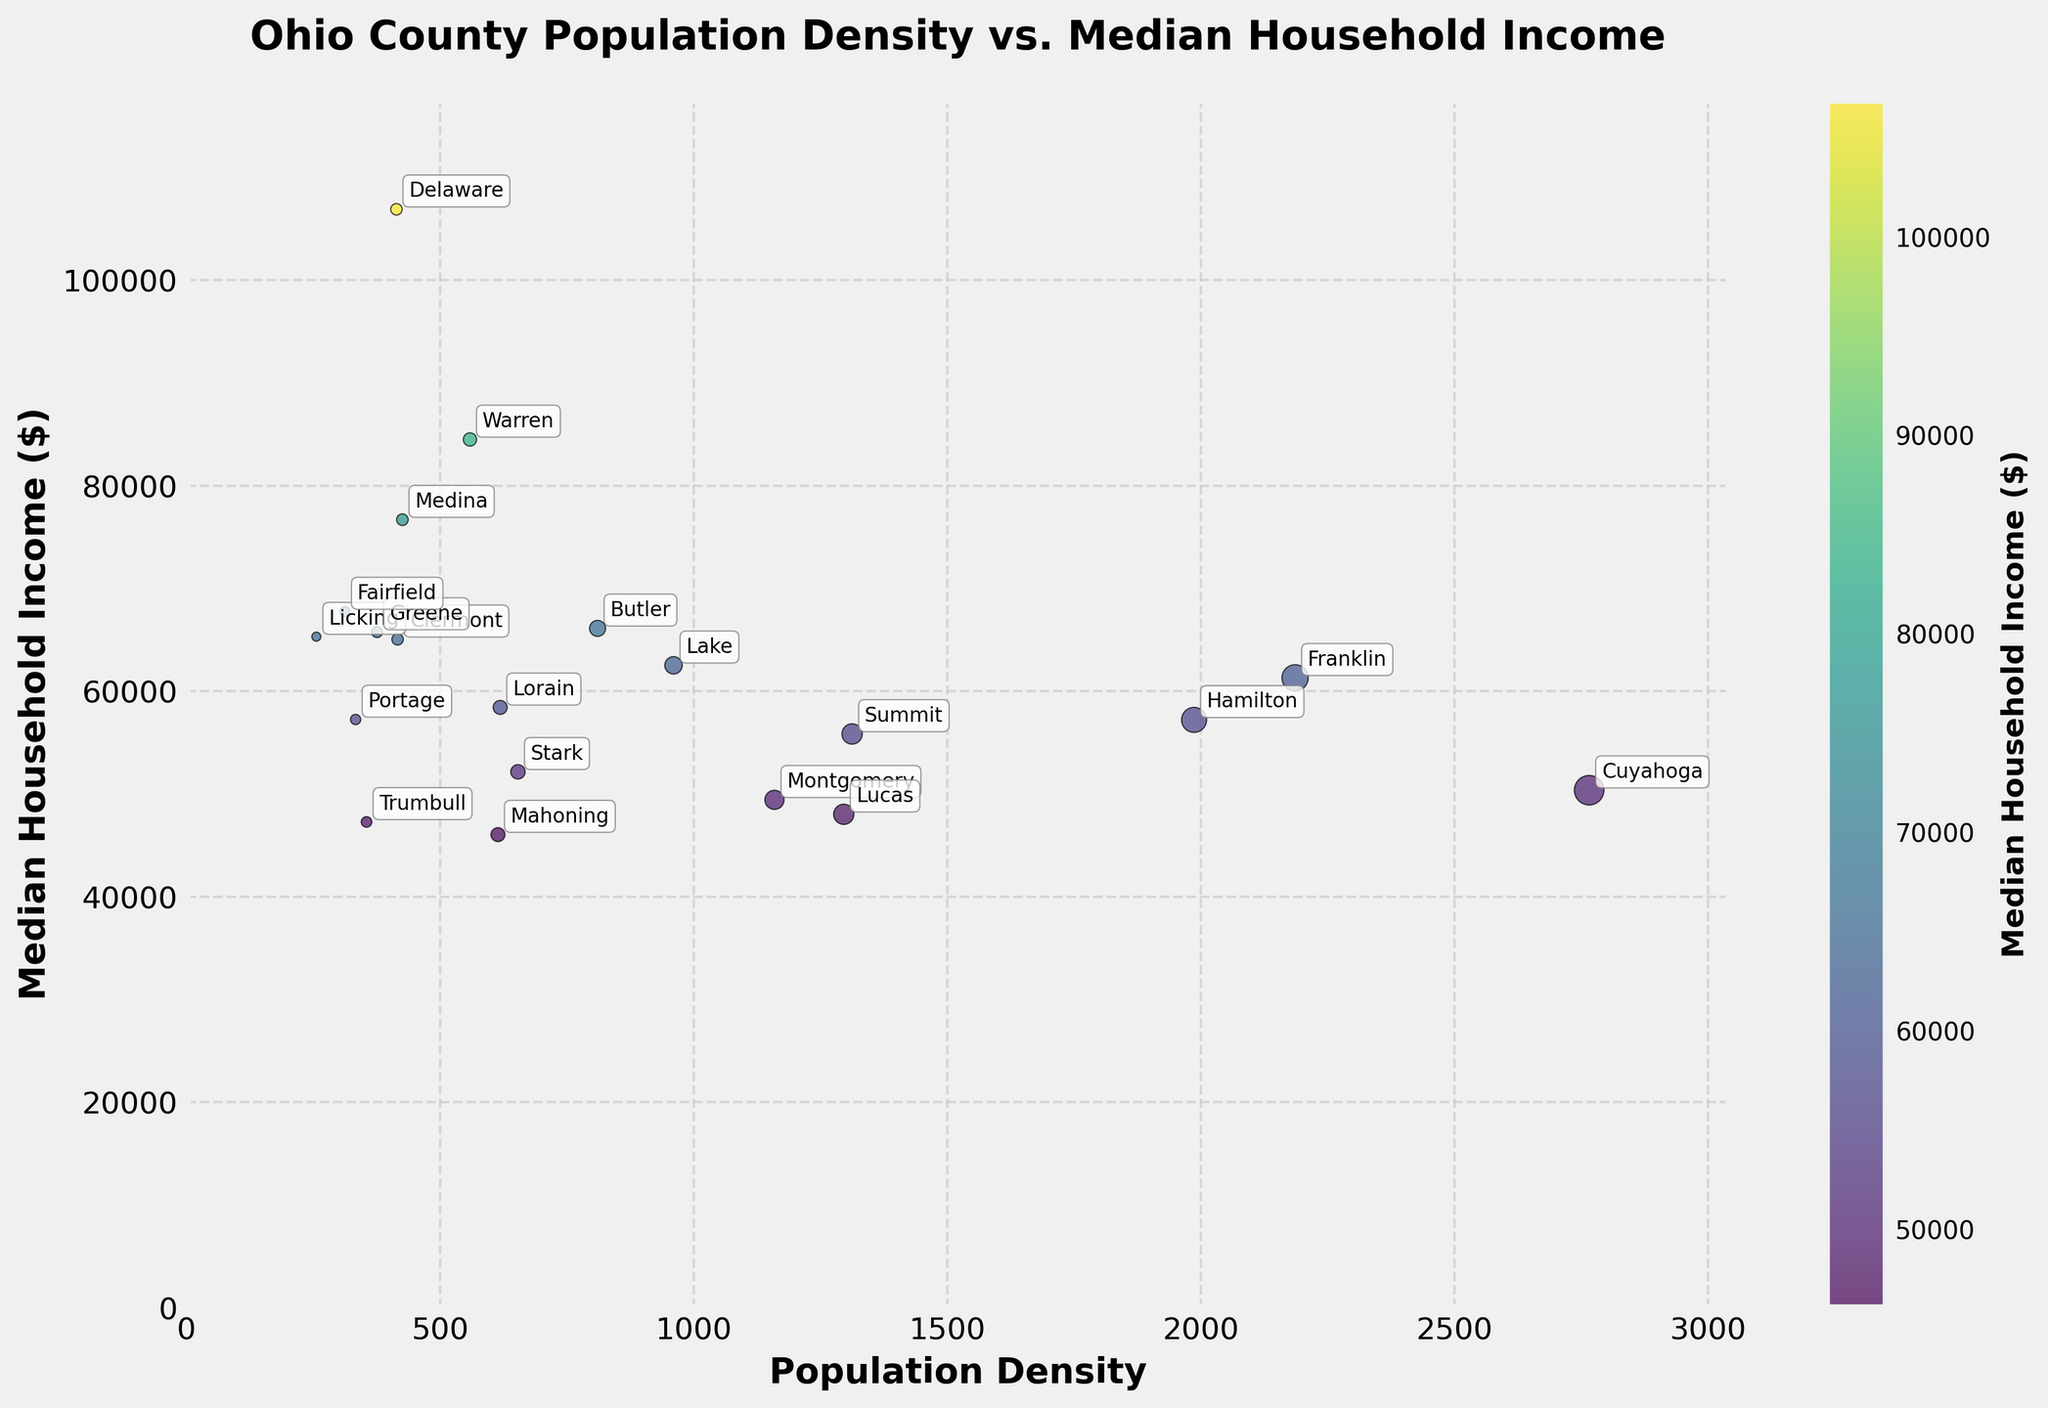What is the title of the figure? The title is usually found above the main plot area, providing a brief description of the chart's content. In this figure, the title is "Ohio County Population Density vs. Median Household Income".
Answer: Ohio County Population Density vs. Median Household Income What are the labels on the x-axis and y-axis? The labels on the x-axis and y-axis describe what each axis represents. The x-axis label is "Population Density" and the y-axis label is "Median Household Income ($)".
Answer: Population Density, Median Household Income ($) Which county has the highest median household income? To find this, look for the point with the highest y-value on the chart. Based on the annotations, Delaware County has the highest median household income.
Answer: Delaware Which county has the highest population density? To answer this, find the point with the highest x-value on the chart. The annotation shows that Cuyahoga County has the highest population density.
Answer: Cuyahoga What do the colors in the scatter plot represent? The color of each point is explained by the color bar on the right side of the plot, indicating that colors represent "Median Household Income ($)".
Answer: Median Household Income ($) How many counties are represented in the plot? Count the number of points (or annotations) in the scatter plot. There are 20 counties represented in the plot.
Answer: 20 Which two counties have the closest median household incomes? To find the answer, visually scan the plot and identify points that are closest in their y-values. Clermont and Butler counties have similar median household incomes.
Answer: Clermont and Butler What is the approximate median household income for Franklin County? Franklin County’s point on the graph appears just above 60,000 on the y-axis. The exact median household income when referring to the annotation for Franklin is around $61305.
Answer: $61305 Which county has the lowest population density? Look for the county with the smallest x-value. The annotation shows that Licking County has the lowest population density.
Answer: Licking 